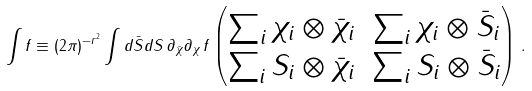Convert formula to latex. <formula><loc_0><loc_0><loc_500><loc_500>\int f \equiv ( 2 \pi ) ^ { - r ^ { 2 } } \int d \bar { S } d S \, \partial _ { \bar { \chi } } \partial _ { \chi } \, f \begin{pmatrix} \sum _ { i } \chi _ { i } \otimes \bar { \chi } _ { i } & \sum _ { i } \chi _ { i } \otimes \bar { S } _ { i } \\ \sum _ { i } S _ { i } \otimes \bar { \chi } _ { i } & \sum _ { i } S _ { i } \otimes \bar { S } _ { i } \end{pmatrix} \, .</formula> 